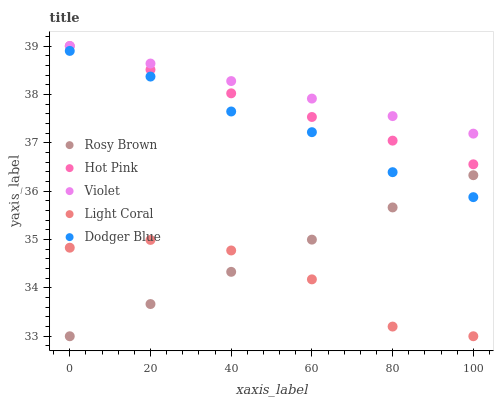Does Light Coral have the minimum area under the curve?
Answer yes or no. Yes. Does Violet have the maximum area under the curve?
Answer yes or no. Yes. Does Rosy Brown have the minimum area under the curve?
Answer yes or no. No. Does Rosy Brown have the maximum area under the curve?
Answer yes or no. No. Is Violet the smoothest?
Answer yes or no. Yes. Is Light Coral the roughest?
Answer yes or no. Yes. Is Rosy Brown the smoothest?
Answer yes or no. No. Is Rosy Brown the roughest?
Answer yes or no. No. Does Light Coral have the lowest value?
Answer yes or no. Yes. Does Violet have the lowest value?
Answer yes or no. No. Does Hot Pink have the highest value?
Answer yes or no. Yes. Does Rosy Brown have the highest value?
Answer yes or no. No. Is Light Coral less than Violet?
Answer yes or no. Yes. Is Hot Pink greater than Light Coral?
Answer yes or no. Yes. Does Violet intersect Hot Pink?
Answer yes or no. Yes. Is Violet less than Hot Pink?
Answer yes or no. No. Is Violet greater than Hot Pink?
Answer yes or no. No. Does Light Coral intersect Violet?
Answer yes or no. No. 